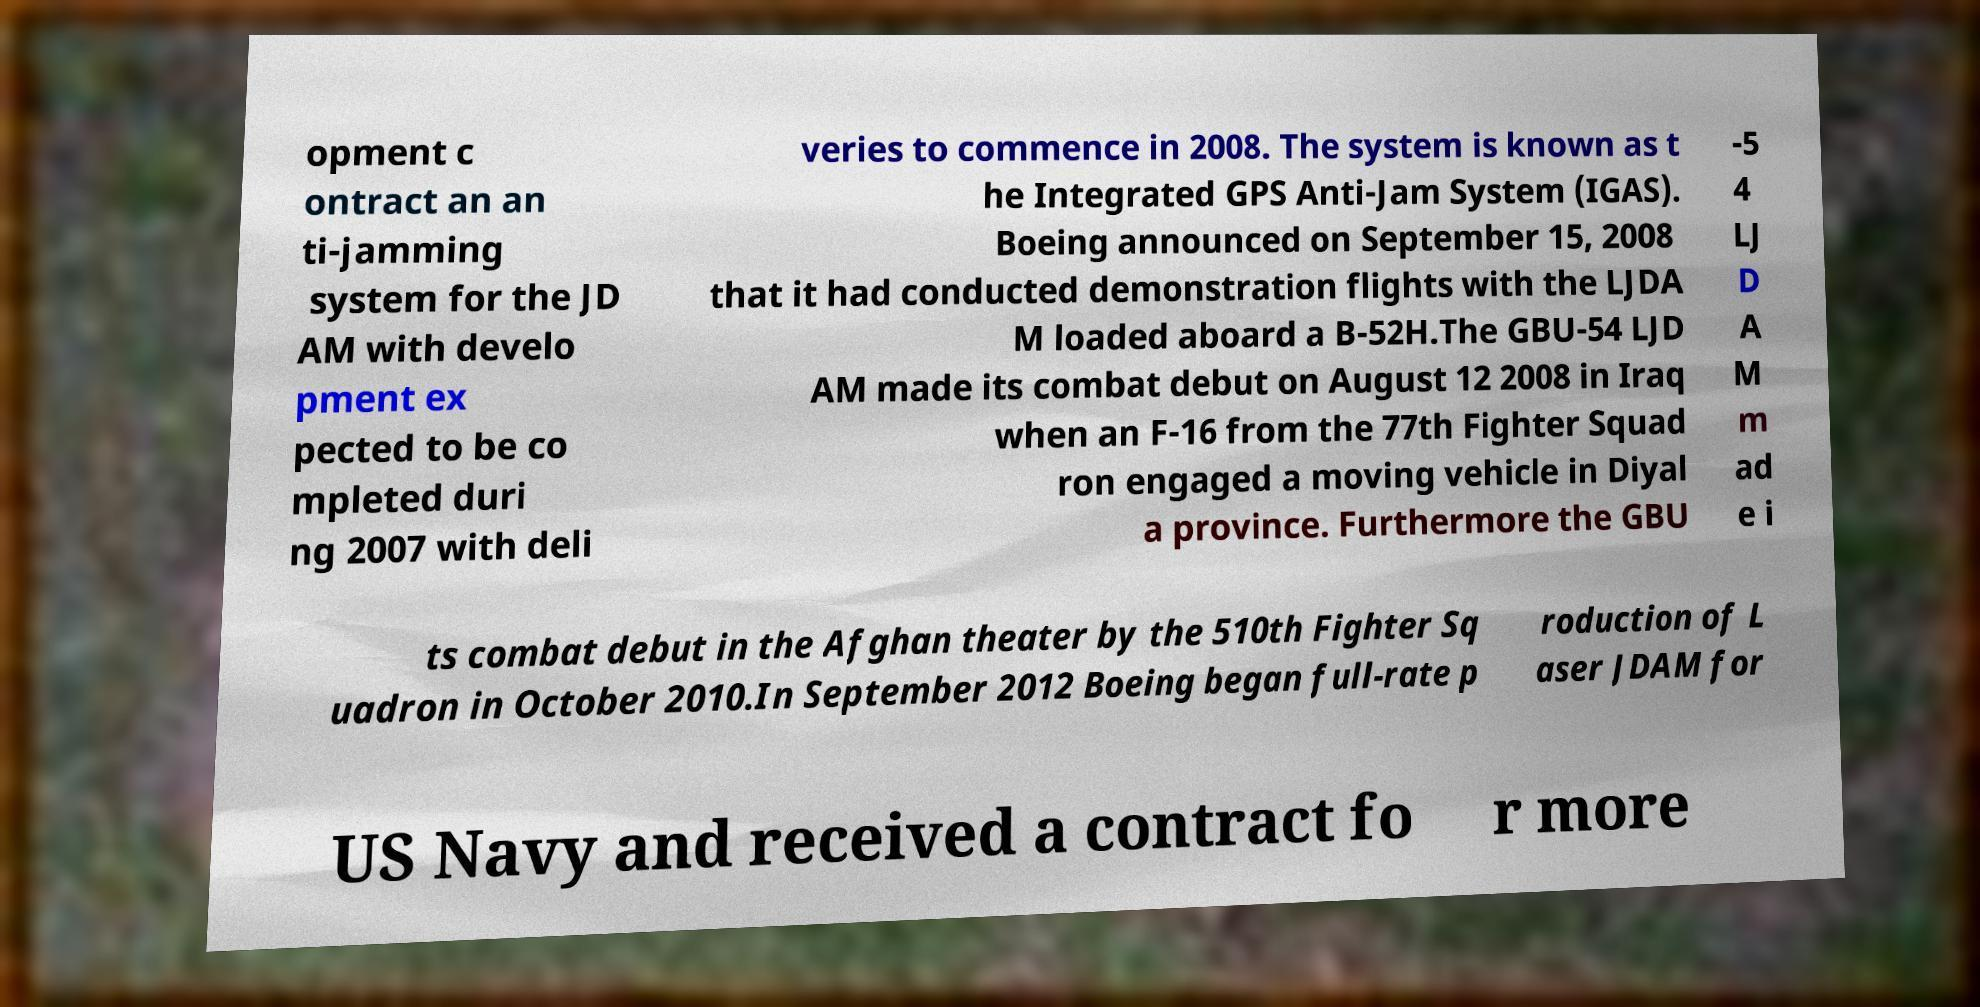Please identify and transcribe the text found in this image. opment c ontract an an ti-jamming system for the JD AM with develo pment ex pected to be co mpleted duri ng 2007 with deli veries to commence in 2008. The system is known as t he Integrated GPS Anti-Jam System (IGAS). Boeing announced on September 15, 2008 that it had conducted demonstration flights with the LJDA M loaded aboard a B-52H.The GBU-54 LJD AM made its combat debut on August 12 2008 in Iraq when an F-16 from the 77th Fighter Squad ron engaged a moving vehicle in Diyal a province. Furthermore the GBU -5 4 LJ D A M m ad e i ts combat debut in the Afghan theater by the 510th Fighter Sq uadron in October 2010.In September 2012 Boeing began full-rate p roduction of L aser JDAM for US Navy and received a contract fo r more 